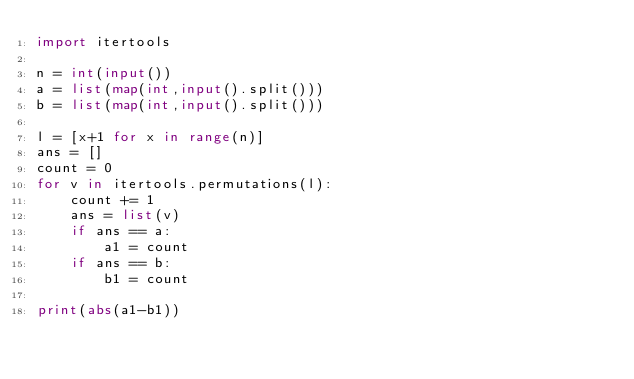<code> <loc_0><loc_0><loc_500><loc_500><_Python_>import itertools

n = int(input())
a = list(map(int,input().split()))
b = list(map(int,input().split()))

l = [x+1 for x in range(n)]
ans = []
count = 0
for v in itertools.permutations(l):
    count += 1
    ans = list(v)
    if ans == a:
        a1 = count
    if ans == b:
        b1 = count

print(abs(a1-b1))
        


</code> 